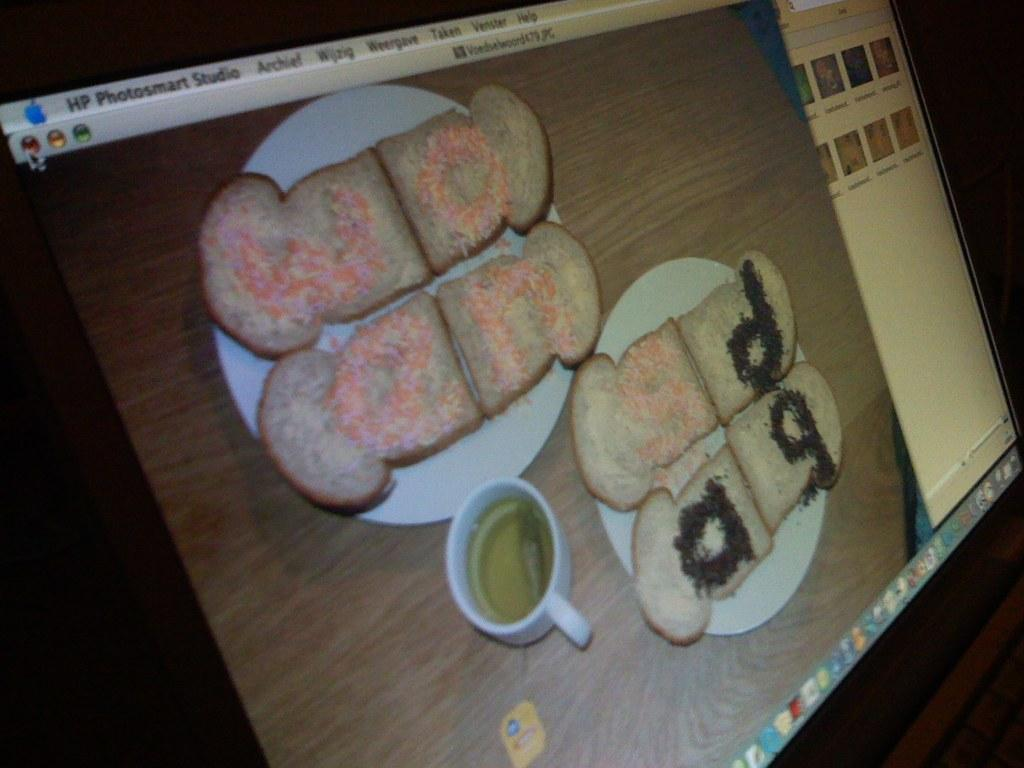What is the main object in the image? There is a monitor screen in the image. Can you see a beetle crawling on the monitor screen in the image? There is no beetle present on the monitor screen in the image. What type of art is displayed on the monitor screen in the image? The provided facts do not mention any art displayed on the monitor screen, so we cannot answer this question. 